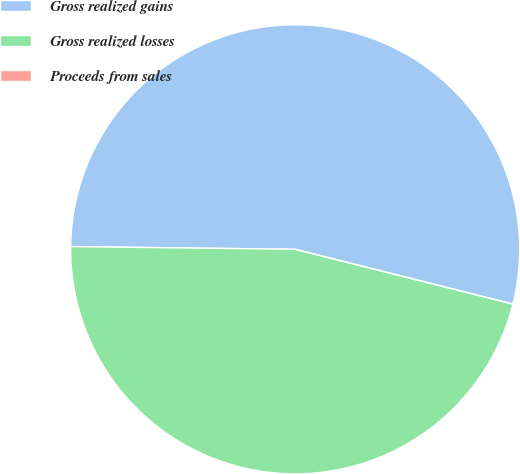Convert chart to OTSL. <chart><loc_0><loc_0><loc_500><loc_500><pie_chart><fcel>Gross realized gains<fcel>Gross realized losses<fcel>Proceeds from sales<nl><fcel>53.73%<fcel>46.27%<fcel>0.0%<nl></chart> 